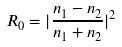Convert formula to latex. <formula><loc_0><loc_0><loc_500><loc_500>R _ { 0 } = | \frac { n _ { 1 } - n _ { 2 } } { n _ { 1 } + n _ { 2 } } | ^ { 2 }</formula> 